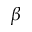Convert formula to latex. <formula><loc_0><loc_0><loc_500><loc_500>\beta</formula> 